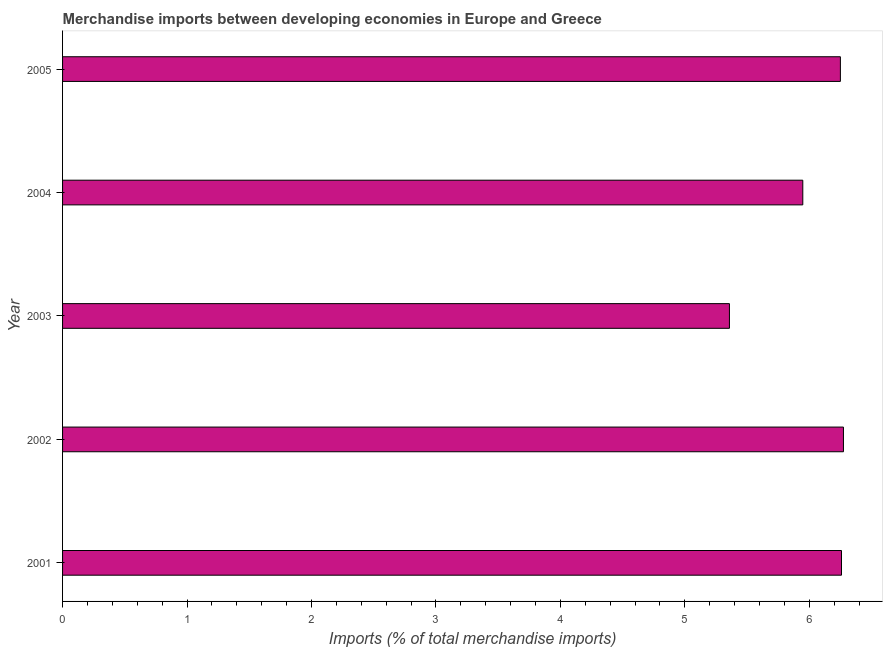Does the graph contain grids?
Provide a succinct answer. No. What is the title of the graph?
Your answer should be compact. Merchandise imports between developing economies in Europe and Greece. What is the label or title of the X-axis?
Your answer should be compact. Imports (% of total merchandise imports). What is the label or title of the Y-axis?
Your response must be concise. Year. What is the merchandise imports in 2005?
Your answer should be very brief. 6.25. Across all years, what is the maximum merchandise imports?
Make the answer very short. 6.27. Across all years, what is the minimum merchandise imports?
Offer a very short reply. 5.36. In which year was the merchandise imports maximum?
Your answer should be very brief. 2002. What is the sum of the merchandise imports?
Provide a short and direct response. 30.09. What is the difference between the merchandise imports in 2002 and 2004?
Your answer should be very brief. 0.33. What is the average merchandise imports per year?
Ensure brevity in your answer.  6.02. What is the median merchandise imports?
Your answer should be compact. 6.25. In how many years, is the merchandise imports greater than 4.2 %?
Your answer should be very brief. 5. Do a majority of the years between 2003 and 2005 (inclusive) have merchandise imports greater than 1.4 %?
Give a very brief answer. Yes. What is the difference between the highest and the second highest merchandise imports?
Your answer should be very brief. 0.02. Is the sum of the merchandise imports in 2002 and 2004 greater than the maximum merchandise imports across all years?
Your answer should be compact. Yes. Are all the bars in the graph horizontal?
Your answer should be compact. Yes. What is the Imports (% of total merchandise imports) of 2001?
Ensure brevity in your answer.  6.26. What is the Imports (% of total merchandise imports) of 2002?
Keep it short and to the point. 6.27. What is the Imports (% of total merchandise imports) in 2003?
Keep it short and to the point. 5.36. What is the Imports (% of total merchandise imports) of 2004?
Your answer should be compact. 5.95. What is the Imports (% of total merchandise imports) of 2005?
Ensure brevity in your answer.  6.25. What is the difference between the Imports (% of total merchandise imports) in 2001 and 2002?
Provide a succinct answer. -0.02. What is the difference between the Imports (% of total merchandise imports) in 2001 and 2003?
Offer a terse response. 0.9. What is the difference between the Imports (% of total merchandise imports) in 2001 and 2004?
Your answer should be very brief. 0.31. What is the difference between the Imports (% of total merchandise imports) in 2001 and 2005?
Offer a terse response. 0.01. What is the difference between the Imports (% of total merchandise imports) in 2002 and 2003?
Give a very brief answer. 0.92. What is the difference between the Imports (% of total merchandise imports) in 2002 and 2004?
Offer a very short reply. 0.33. What is the difference between the Imports (% of total merchandise imports) in 2002 and 2005?
Give a very brief answer. 0.02. What is the difference between the Imports (% of total merchandise imports) in 2003 and 2004?
Keep it short and to the point. -0.59. What is the difference between the Imports (% of total merchandise imports) in 2003 and 2005?
Offer a very short reply. -0.89. What is the difference between the Imports (% of total merchandise imports) in 2004 and 2005?
Provide a succinct answer. -0.3. What is the ratio of the Imports (% of total merchandise imports) in 2001 to that in 2003?
Ensure brevity in your answer.  1.17. What is the ratio of the Imports (% of total merchandise imports) in 2001 to that in 2004?
Offer a very short reply. 1.05. What is the ratio of the Imports (% of total merchandise imports) in 2001 to that in 2005?
Offer a very short reply. 1. What is the ratio of the Imports (% of total merchandise imports) in 2002 to that in 2003?
Your answer should be compact. 1.17. What is the ratio of the Imports (% of total merchandise imports) in 2002 to that in 2004?
Keep it short and to the point. 1.05. What is the ratio of the Imports (% of total merchandise imports) in 2002 to that in 2005?
Your answer should be compact. 1. What is the ratio of the Imports (% of total merchandise imports) in 2003 to that in 2004?
Offer a terse response. 0.9. What is the ratio of the Imports (% of total merchandise imports) in 2003 to that in 2005?
Provide a succinct answer. 0.86. 